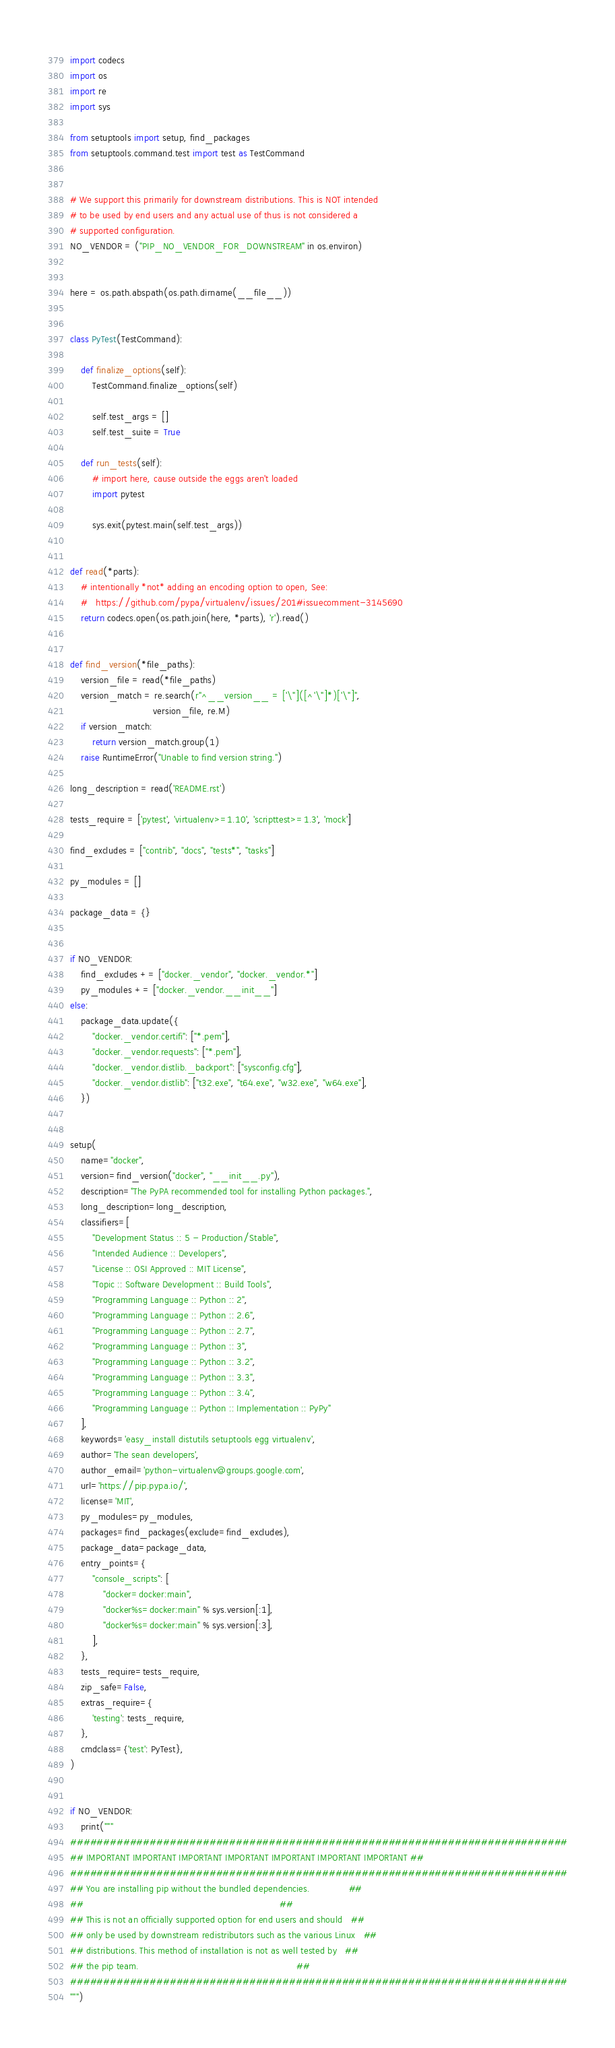Convert code to text. <code><loc_0><loc_0><loc_500><loc_500><_Python_>import codecs
import os
import re
import sys

from setuptools import setup, find_packages
from setuptools.command.test import test as TestCommand


# We support this primarily for downstream distributions. This is NOT intended
# to be used by end users and any actual use of thus is not considered a
# supported configuration.
NO_VENDOR = ("PIP_NO_VENDOR_FOR_DOWNSTREAM" in os.environ)


here = os.path.abspath(os.path.dirname(__file__))


class PyTest(TestCommand):

    def finalize_options(self):
        TestCommand.finalize_options(self)

        self.test_args = []
        self.test_suite = True

    def run_tests(self):
        # import here, cause outside the eggs aren't loaded
        import pytest

        sys.exit(pytest.main(self.test_args))


def read(*parts):
    # intentionally *not* adding an encoding option to open, See:
    #   https://github.com/pypa/virtualenv/issues/201#issuecomment-3145690
    return codecs.open(os.path.join(here, *parts), 'r').read()


def find_version(*file_paths):
    version_file = read(*file_paths)
    version_match = re.search(r"^__version__ = ['\"]([^'\"]*)['\"]",
                              version_file, re.M)
    if version_match:
        return version_match.group(1)
    raise RuntimeError("Unable to find version string.")

long_description = read('README.rst')

tests_require = ['pytest', 'virtualenv>=1.10', 'scripttest>=1.3', 'mock']

find_excludes = ["contrib", "docs", "tests*", "tasks"]

py_modules = []

package_data = {}


if NO_VENDOR:
    find_excludes += ["docker._vendor", "docker._vendor.*"]
    py_modules += ["docker._vendor.__init__"]
else:
    package_data.update({
        "docker._vendor.certifi": ["*.pem"],
        "docker._vendor.requests": ["*.pem"],
        "docker._vendor.distlib._backport": ["sysconfig.cfg"],
        "docker._vendor.distlib": ["t32.exe", "t64.exe", "w32.exe", "w64.exe"],
    })


setup(
    name="docker",
    version=find_version("docker", "__init__.py"),
    description="The PyPA recommended tool for installing Python packages.",
    long_description=long_description,
    classifiers=[
        "Development Status :: 5 - Production/Stable",
        "Intended Audience :: Developers",
        "License :: OSI Approved :: MIT License",
        "Topic :: Software Development :: Build Tools",
        "Programming Language :: Python :: 2",
        "Programming Language :: Python :: 2.6",
        "Programming Language :: Python :: 2.7",
        "Programming Language :: Python :: 3",
        "Programming Language :: Python :: 3.2",
        "Programming Language :: Python :: 3.3",
        "Programming Language :: Python :: 3.4",
        "Programming Language :: Python :: Implementation :: PyPy"
    ],
    keywords='easy_install distutils setuptools egg virtualenv',
    author='The sean developers',
    author_email='python-virtualenv@groups.google.com',
    url='https://pip.pypa.io/',
    license='MIT',
    py_modules=py_modules,
    packages=find_packages(exclude=find_excludes),
    package_data=package_data,
    entry_points={
        "console_scripts": [
            "docker=docker:main",
            "docker%s=docker:main" % sys.version[:1],
            "docker%s=docker:main" % sys.version[:3],
        ],
    },
    tests_require=tests_require,
    zip_safe=False,
    extras_require={
        'testing': tests_require,
    },
    cmdclass={'test': PyTest},
)


if NO_VENDOR:
    print("""
###########################################################################
## IMPORTANT IMPORTANT IMPORTANT IMPORTANT IMPORTANT IMPORTANT IMPORTANT ##
###########################################################################
## You are installing pip without the bundled dependencies.              ##
##                                                                       ##
## This is not an officially supported option for end users and should   ##
## only be used by downstream redistributors such as the various Linux   ##
## distributions. This method of installation is not as well tested by   ##
## the pip team.                                                         ##
###########################################################################
""")
</code> 